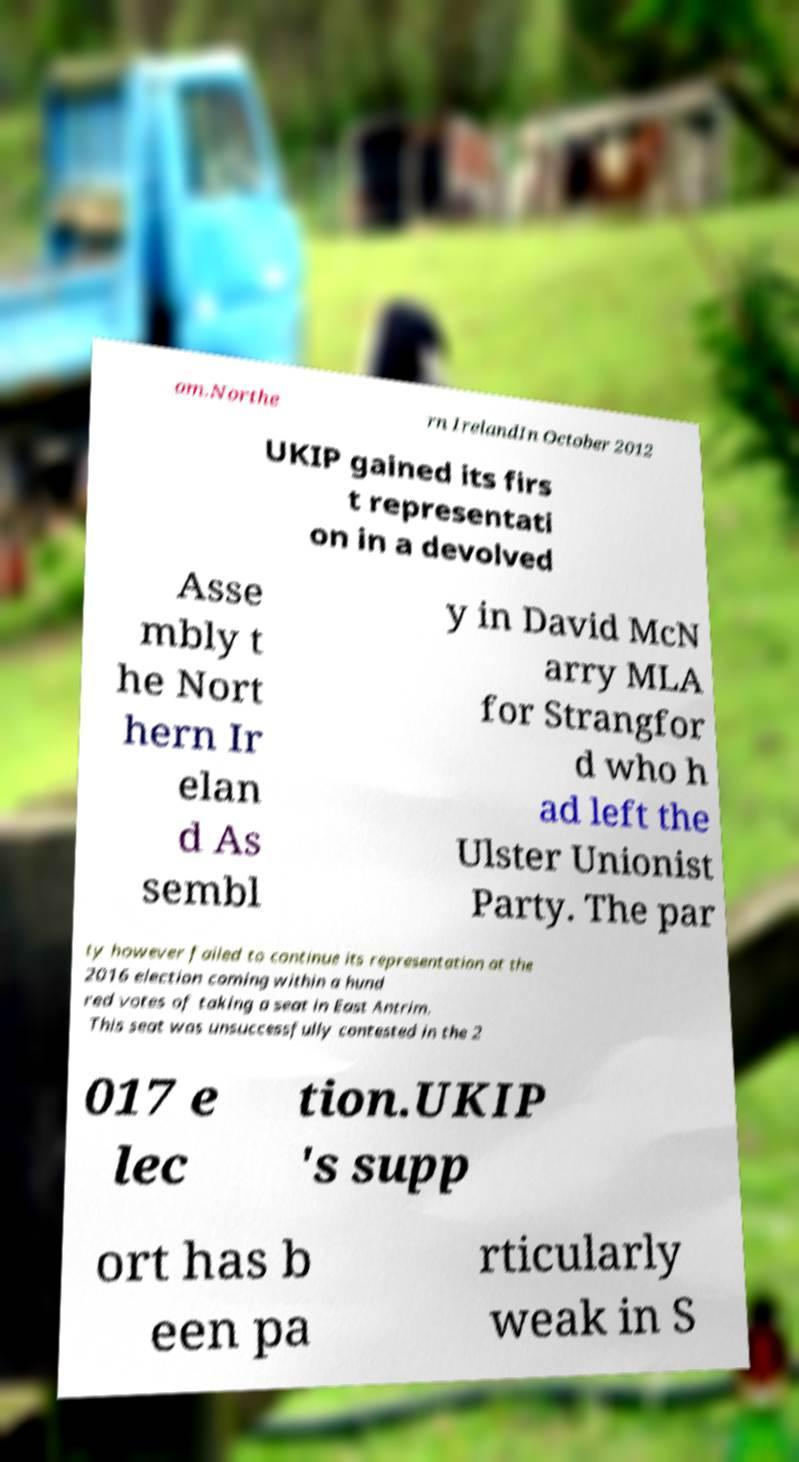Could you extract and type out the text from this image? om.Northe rn IrelandIn October 2012 UKIP gained its firs t representati on in a devolved Asse mbly t he Nort hern Ir elan d As sembl y in David McN arry MLA for Strangfor d who h ad left the Ulster Unionist Party. The par ty however failed to continue its representation at the 2016 election coming within a hund red votes of taking a seat in East Antrim. This seat was unsuccessfully contested in the 2 017 e lec tion.UKIP 's supp ort has b een pa rticularly weak in S 